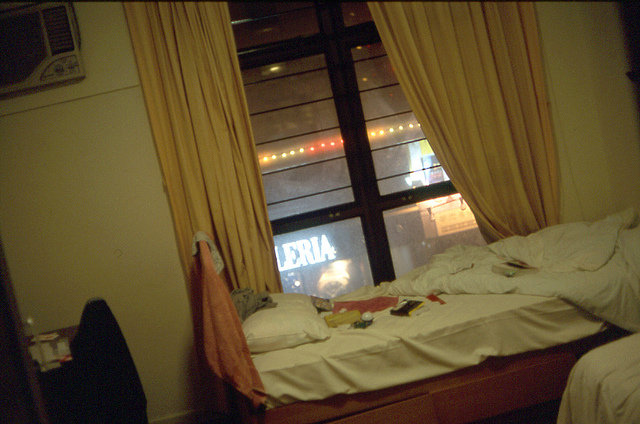Extract all visible text content from this image. ERIA 